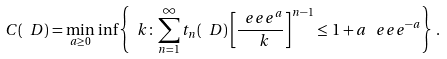<formula> <loc_0><loc_0><loc_500><loc_500>C ( \ D ) = \min _ { a \geq 0 } \, \inf \left \{ \ k \colon \sum _ { n = 1 } ^ { \infty } t _ { n } ( \ D ) \left [ \frac { \ e e e ^ { a } } { \ k } \right ] ^ { n - 1 } \leq \, 1 + a \, \ e e e ^ { - a } \right \} \, .</formula> 